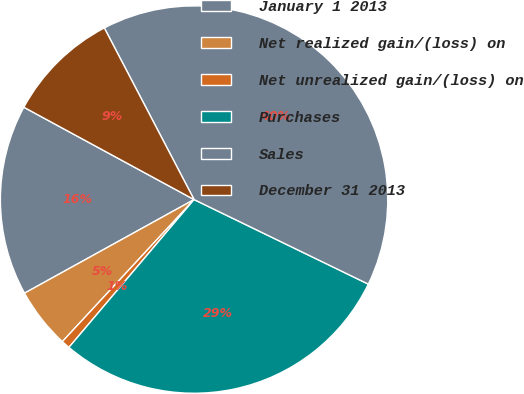<chart> <loc_0><loc_0><loc_500><loc_500><pie_chart><fcel>January 1 2013<fcel>Net realized gain/(loss) on<fcel>Net unrealized gain/(loss) on<fcel>Purchases<fcel>Sales<fcel>December 31 2013<nl><fcel>15.94%<fcel>5.07%<fcel>0.72%<fcel>28.99%<fcel>39.86%<fcel>9.42%<nl></chart> 